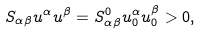<formula> <loc_0><loc_0><loc_500><loc_500>S _ { \alpha \beta } u ^ { \alpha } u ^ { \beta } = S ^ { 0 } _ { \alpha \beta } u ^ { \alpha } _ { 0 } u ^ { \beta } _ { 0 } > 0 ,</formula> 